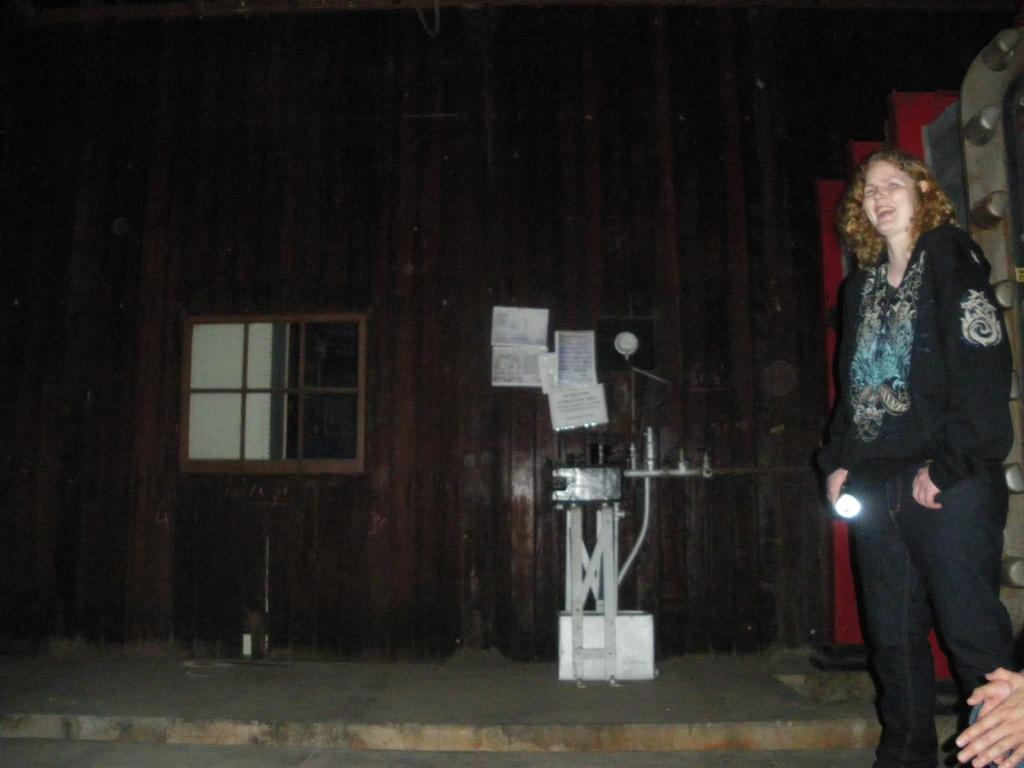Who can be seen in the image? There are people in the image, including a woman. What is the woman doing in the image? The woman is smiling in the image. What objects are made of metal in the image? There are metal rods in the image. What can be found on the wall in the image? There are papers on the wall in the image. What type of comb is being used by the woman in the image? There is no comb visible in the image. What kind of art is displayed on the wall in the image? The image does not show any art on the wall; it only shows papers. 